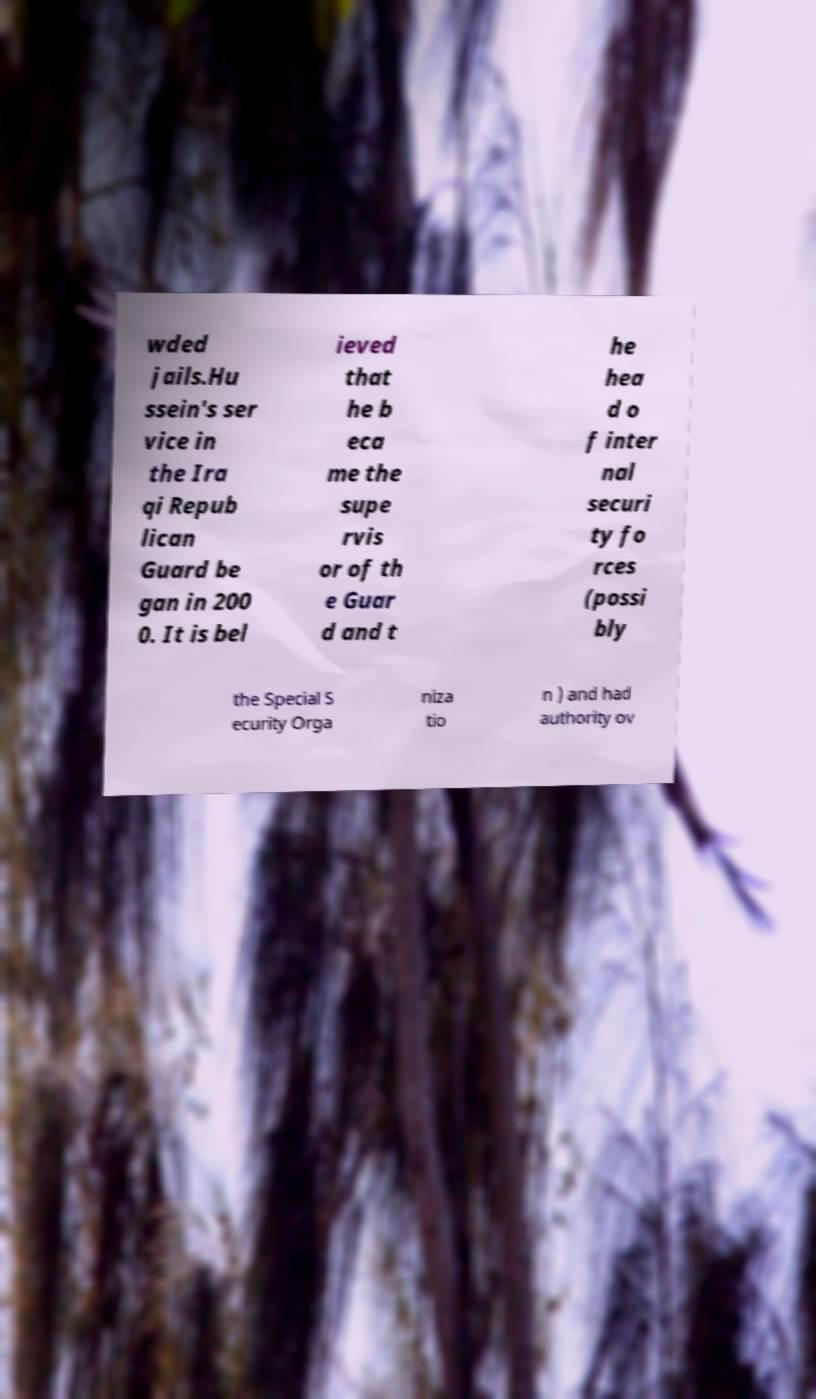Please read and relay the text visible in this image. What does it say? wded jails.Hu ssein's ser vice in the Ira qi Repub lican Guard be gan in 200 0. It is bel ieved that he b eca me the supe rvis or of th e Guar d and t he hea d o f inter nal securi ty fo rces (possi bly the Special S ecurity Orga niza tio n ) and had authority ov 